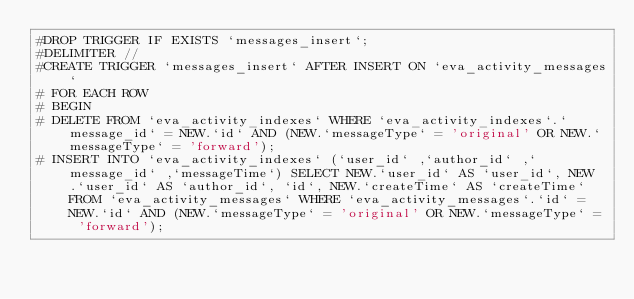Convert code to text. <code><loc_0><loc_0><loc_500><loc_500><_SQL_>#DROP TRIGGER IF EXISTS `messages_insert`;
#DELIMITER //
#CREATE TRIGGER `messages_insert` AFTER INSERT ON `eva_activity_messages`
# FOR EACH ROW 
# BEGIN
# DELETE FROM `eva_activity_indexes` WHERE `eva_activity_indexes`.`message_id` = NEW.`id` AND (NEW.`messageType` = 'original' OR NEW.`messageType` = 'forward');
# INSERT INTO `eva_activity_indexes` (`user_id` ,`author_id` ,`message_id` ,`messageTime`) SELECT NEW.`user_id` AS `user_id`, NEW.`user_id` AS `author_id`, `id`, NEW.`createTime` AS `createTime` FROM `eva_activity_messages` WHERE `eva_activity_messages`.`id` = NEW.`id` AND (NEW.`messageType` = 'original' OR NEW.`messageType` = 'forward');</code> 